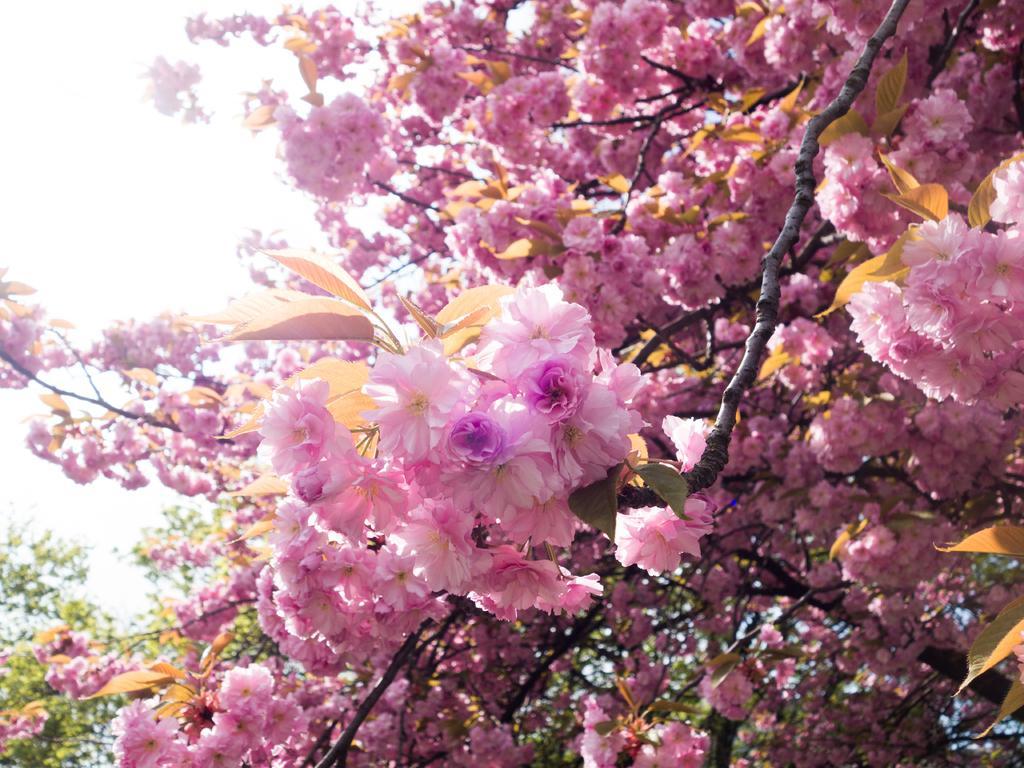How would you summarize this image in a sentence or two? In this image we can see group of flowers on the branches of a tree. In the background, we can see the sky. 